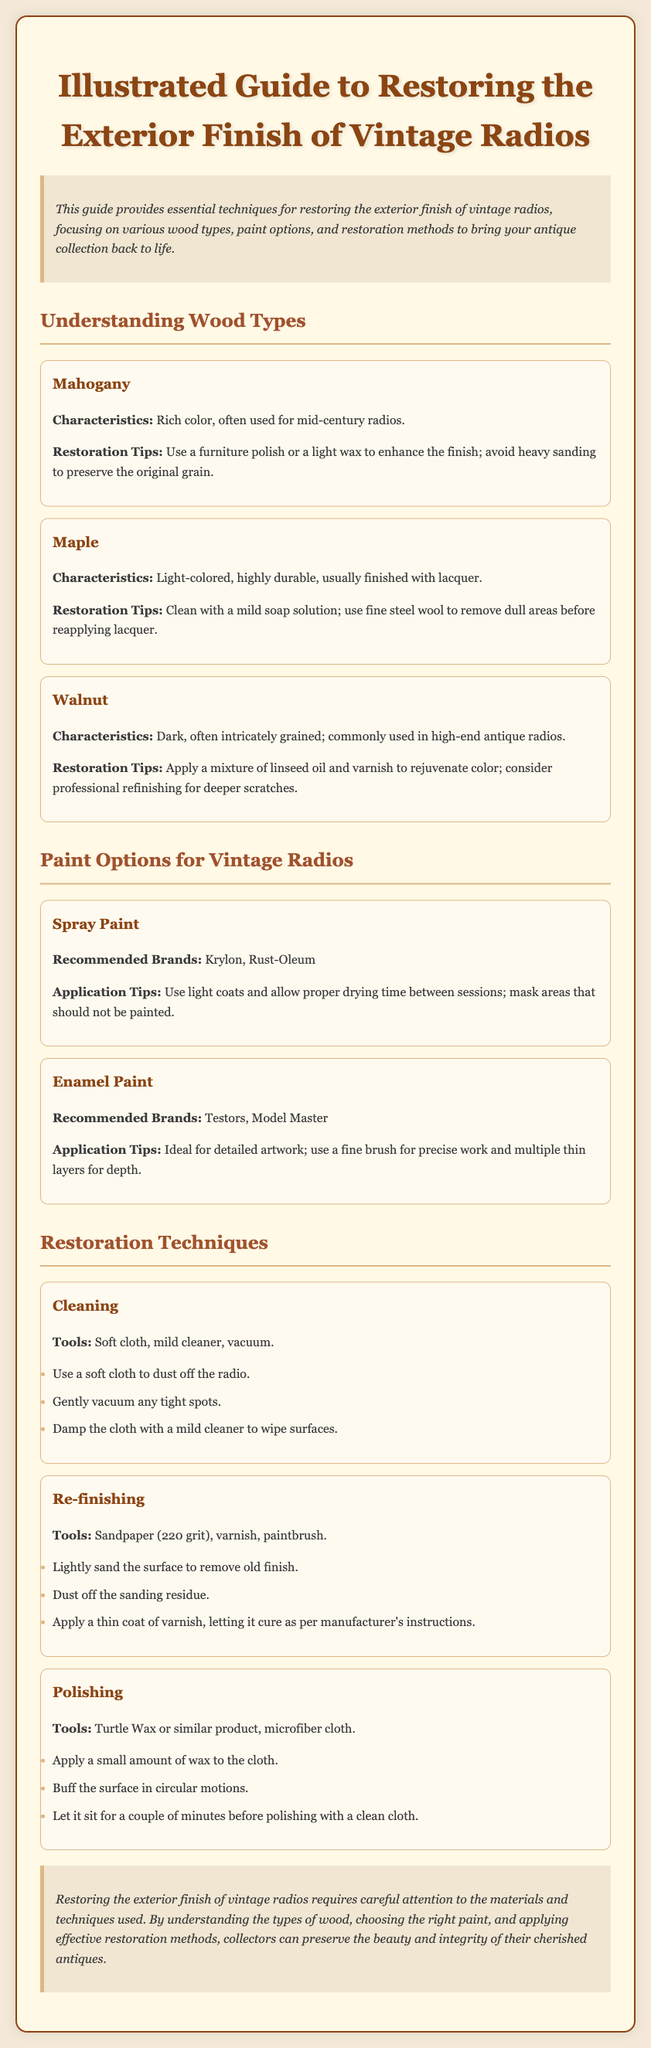What are the characteristics of Mahogany? Mahogany is described as having a rich color and is often used for mid-century radios.
Answer: Rich color, mid-century radios What is the recommended finish for Maple? The guide indicates that Maple is usually finished with lacquer.
Answer: Lacquer Which paint brands are recommended for spray paint? The document lists Krylon and Rust-Oleum as recommended brands for spray paint.
Answer: Krylon, Rust-Oleum What tool is suggested for polishing? The guide suggests using Turtle Wax or a similar product for polishing.
Answer: Turtle Wax What is the sanding grit recommended for re-finishing? The recommended sanding grit mentioned for re-finishing is 220 grit.
Answer: 220 grit What should be used to clean the radio? To clean the radio, a soft cloth, mild cleaner, and vacuum are recommended.
Answer: Soft cloth, mild cleaner, vacuum How should wax be applied during polishing? The guide recommends applying a small amount of wax to the cloth before buffing the surface.
Answer: Small amount of wax to the cloth What type of mixture is suggested for rejuvenating Walnut's color? The suggested mixture for rejuvenating Walnut's color is linseed oil and varnish.
Answer: Linseed oil and varnish How should apply the varnish during re-finishing? The varnish should be applied in a thin coat, letting it cure per the manufacturer's instructions.
Answer: Thin coat, cure per manufacturer's instructions 